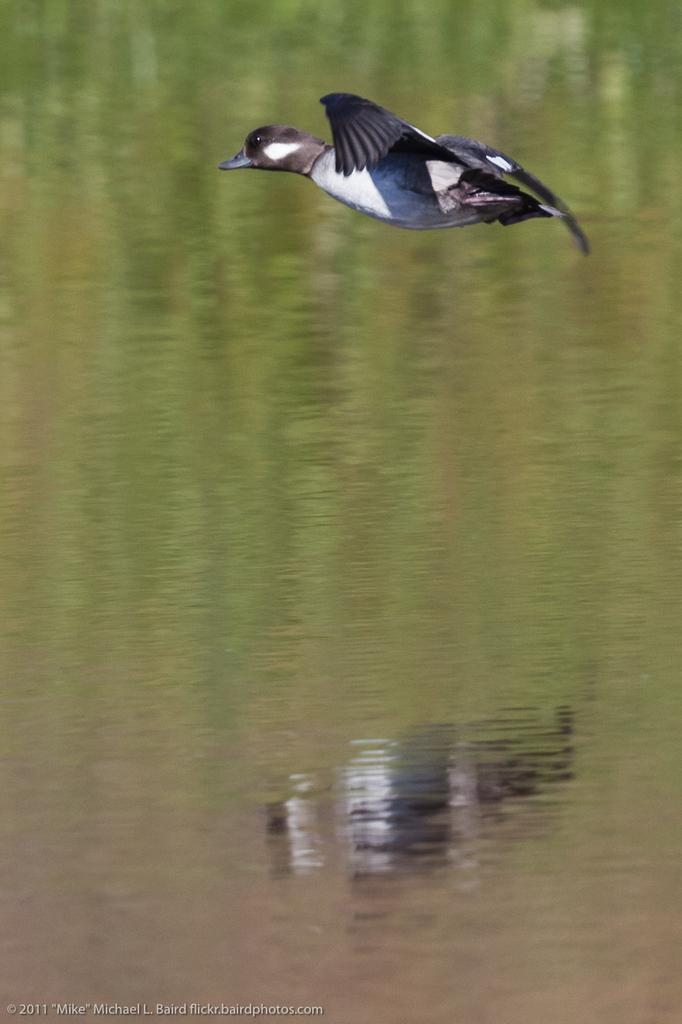What is the main subject of the image? There is a bird flying in the image. What can be seen in the background of the image? There is water visible in the image. What is a unique detail about the bird in the image? The bird's reflection is visible in the water. Can you describe any additional elements in the image? There is a watermark in the bottom left corner of the image. What type of milk is being served in the library in the image? There is no milk or library present in the image; it features a bird flying over water. Is the bird in the image being held in a prison? No, the bird is not being held in a prison; it is flying freely in the image. 